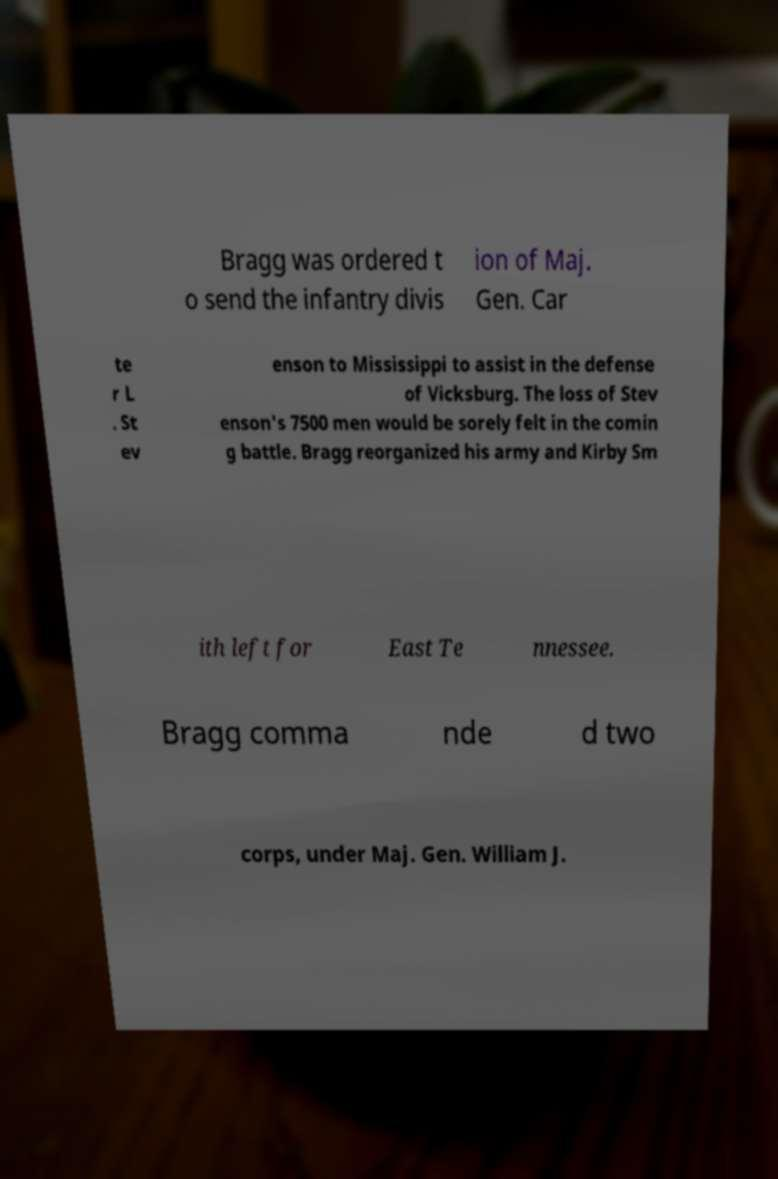Please identify and transcribe the text found in this image. Bragg was ordered t o send the infantry divis ion of Maj. Gen. Car te r L . St ev enson to Mississippi to assist in the defense of Vicksburg. The loss of Stev enson's 7500 men would be sorely felt in the comin g battle. Bragg reorganized his army and Kirby Sm ith left for East Te nnessee. Bragg comma nde d two corps, under Maj. Gen. William J. 